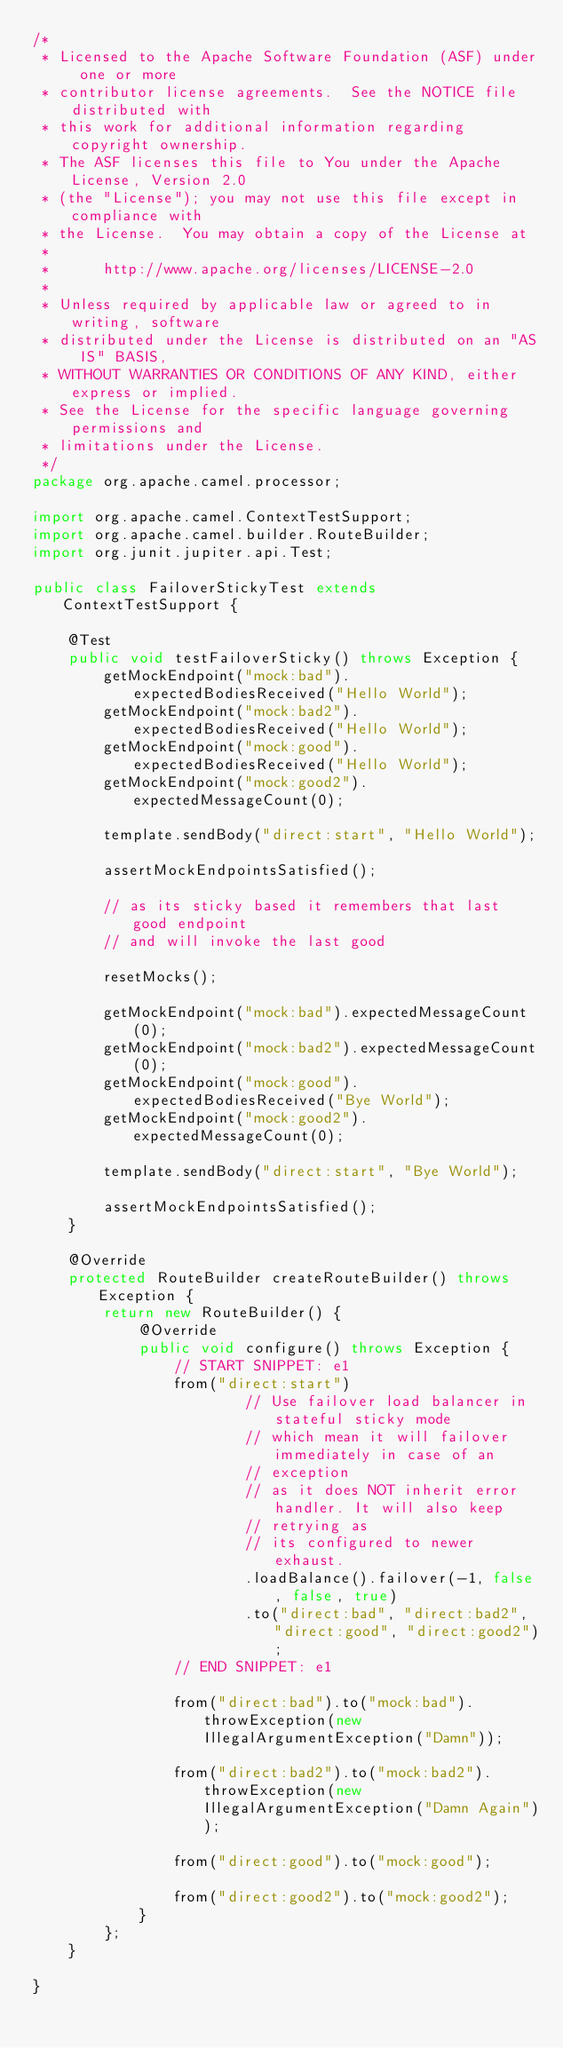<code> <loc_0><loc_0><loc_500><loc_500><_Java_>/*
 * Licensed to the Apache Software Foundation (ASF) under one or more
 * contributor license agreements.  See the NOTICE file distributed with
 * this work for additional information regarding copyright ownership.
 * The ASF licenses this file to You under the Apache License, Version 2.0
 * (the "License"); you may not use this file except in compliance with
 * the License.  You may obtain a copy of the License at
 *
 *      http://www.apache.org/licenses/LICENSE-2.0
 *
 * Unless required by applicable law or agreed to in writing, software
 * distributed under the License is distributed on an "AS IS" BASIS,
 * WITHOUT WARRANTIES OR CONDITIONS OF ANY KIND, either express or implied.
 * See the License for the specific language governing permissions and
 * limitations under the License.
 */
package org.apache.camel.processor;

import org.apache.camel.ContextTestSupport;
import org.apache.camel.builder.RouteBuilder;
import org.junit.jupiter.api.Test;

public class FailoverStickyTest extends ContextTestSupport {

    @Test
    public void testFailoverSticky() throws Exception {
        getMockEndpoint("mock:bad").expectedBodiesReceived("Hello World");
        getMockEndpoint("mock:bad2").expectedBodiesReceived("Hello World");
        getMockEndpoint("mock:good").expectedBodiesReceived("Hello World");
        getMockEndpoint("mock:good2").expectedMessageCount(0);

        template.sendBody("direct:start", "Hello World");

        assertMockEndpointsSatisfied();

        // as its sticky based it remembers that last good endpoint
        // and will invoke the last good

        resetMocks();

        getMockEndpoint("mock:bad").expectedMessageCount(0);
        getMockEndpoint("mock:bad2").expectedMessageCount(0);
        getMockEndpoint("mock:good").expectedBodiesReceived("Bye World");
        getMockEndpoint("mock:good2").expectedMessageCount(0);

        template.sendBody("direct:start", "Bye World");

        assertMockEndpointsSatisfied();
    }

    @Override
    protected RouteBuilder createRouteBuilder() throws Exception {
        return new RouteBuilder() {
            @Override
            public void configure() throws Exception {
                // START SNIPPET: e1
                from("direct:start")
                        // Use failover load balancer in stateful sticky mode
                        // which mean it will failover immediately in case of an
                        // exception
                        // as it does NOT inherit error handler. It will also keep
                        // retrying as
                        // its configured to newer exhaust.
                        .loadBalance().failover(-1, false, false, true)
                        .to("direct:bad", "direct:bad2", "direct:good", "direct:good2");
                // END SNIPPET: e1

                from("direct:bad").to("mock:bad").throwException(new IllegalArgumentException("Damn"));

                from("direct:bad2").to("mock:bad2").throwException(new IllegalArgumentException("Damn Again"));

                from("direct:good").to("mock:good");

                from("direct:good2").to("mock:good2");
            }
        };
    }

}
</code> 